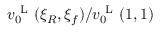<formula> <loc_0><loc_0><loc_500><loc_500>v _ { 0 } ^ { L } ( \xi _ { R } , \xi _ { f } ) / v _ { 0 } ^ { L } ( 1 , 1 )</formula> 